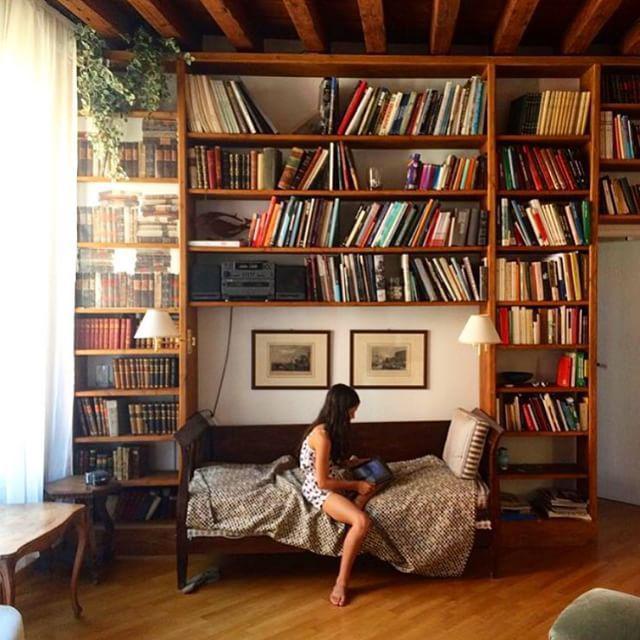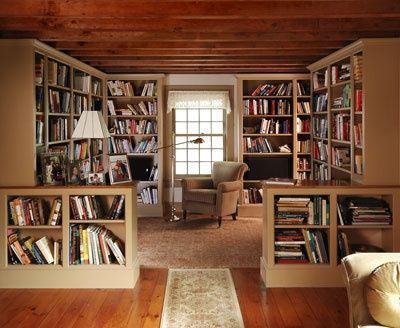The first image is the image on the left, the second image is the image on the right. Assess this claim about the two images: "There are at most three picture frames.". Correct or not? Answer yes or no. Yes. The first image is the image on the left, the second image is the image on the right. Analyze the images presented: Is the assertion "In at least one image there is a cream colored sofa chair with a dark blanket folded and draped over the sofa chair with a yellow lamp to the left of the chair." valid? Answer yes or no. No. 